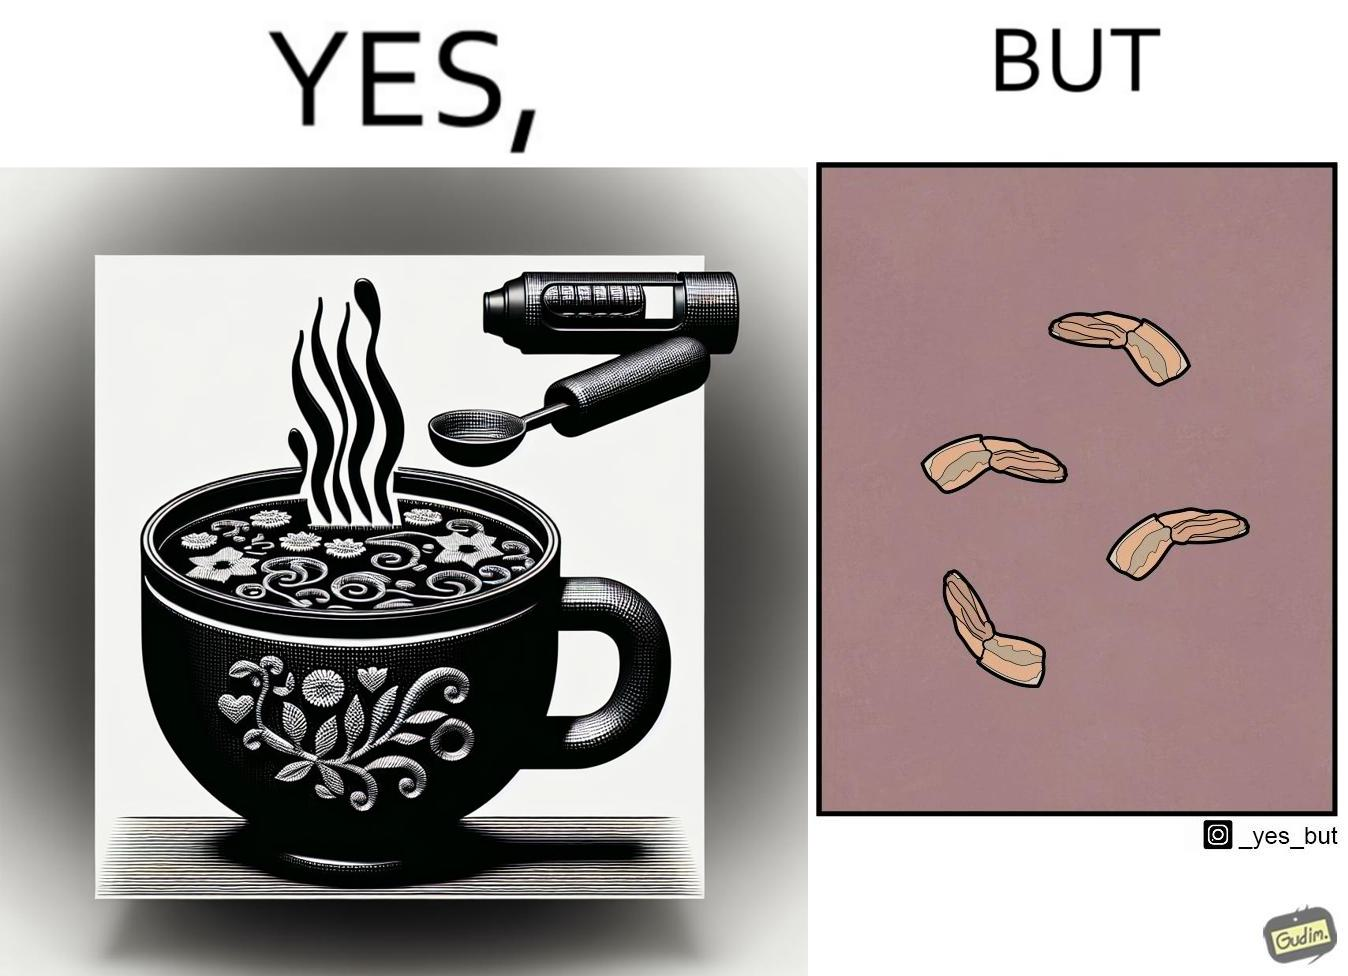What does this image depict? when we drink the whole soup, then  it is very healthy. But people eliminate some things which they don't like. 